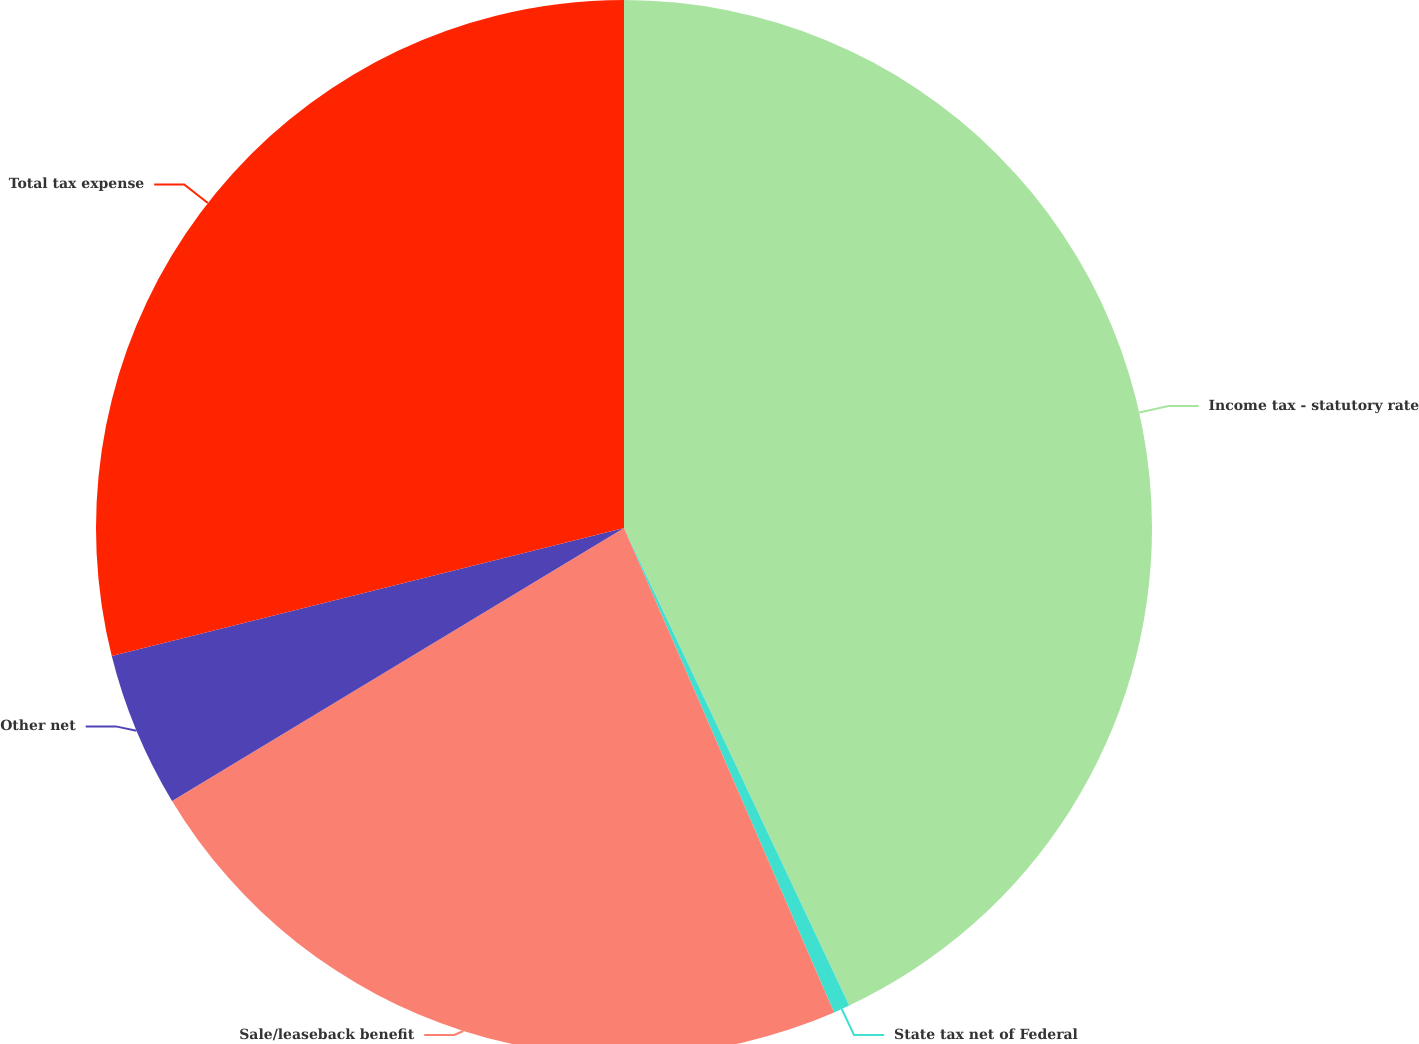Convert chart. <chart><loc_0><loc_0><loc_500><loc_500><pie_chart><fcel>Income tax - statutory rate<fcel>State tax net of Federal<fcel>Sale/leaseback benefit<fcel>Other net<fcel>Total tax expense<nl><fcel>42.99%<fcel>0.5%<fcel>22.87%<fcel>4.75%<fcel>28.9%<nl></chart> 